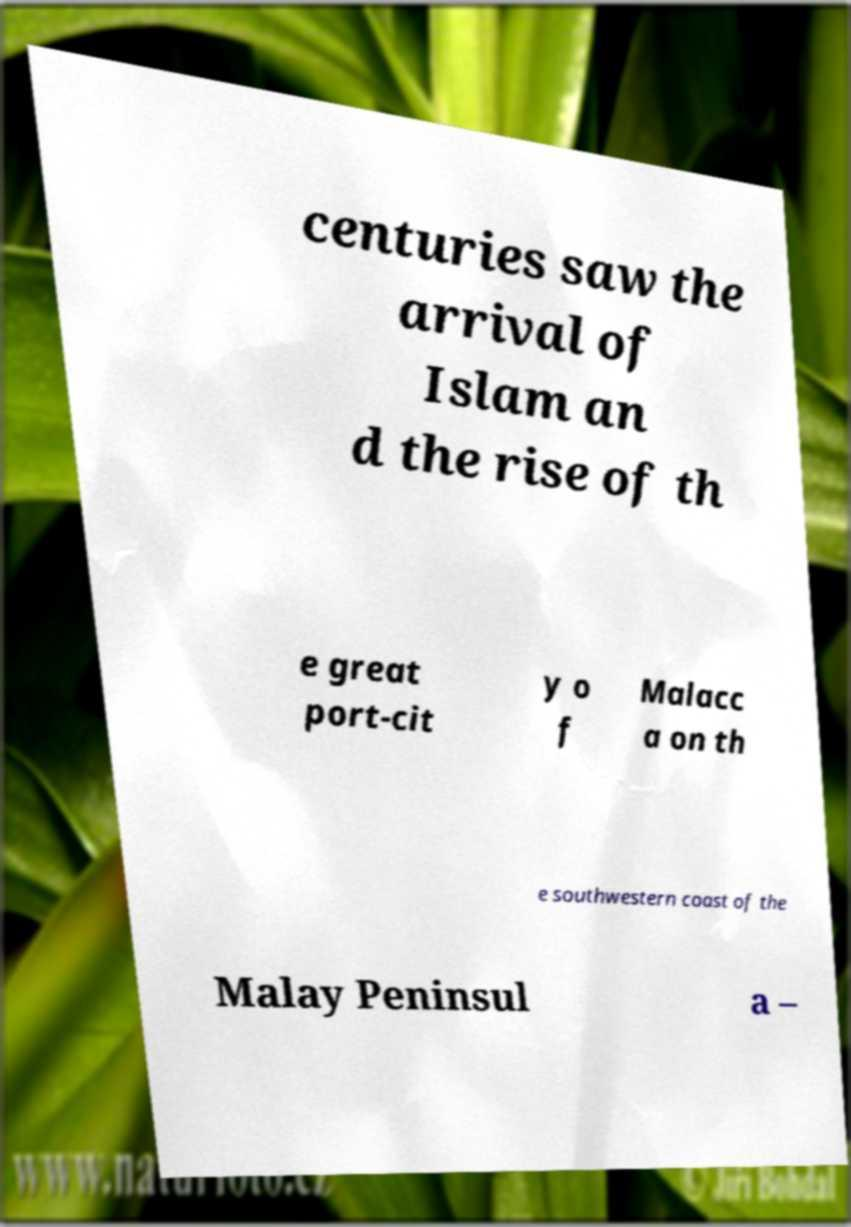Can you read and provide the text displayed in the image?This photo seems to have some interesting text. Can you extract and type it out for me? centuries saw the arrival of Islam an d the rise of th e great port-cit y o f Malacc a on th e southwestern coast of the Malay Peninsul a – 